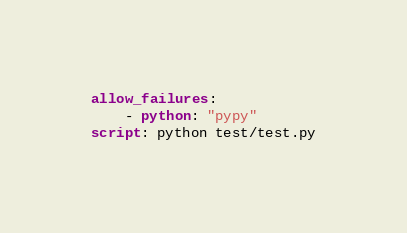<code> <loc_0><loc_0><loc_500><loc_500><_YAML_>allow_failures:
    - python: "pypy"
script: python test/test.py
</code> 